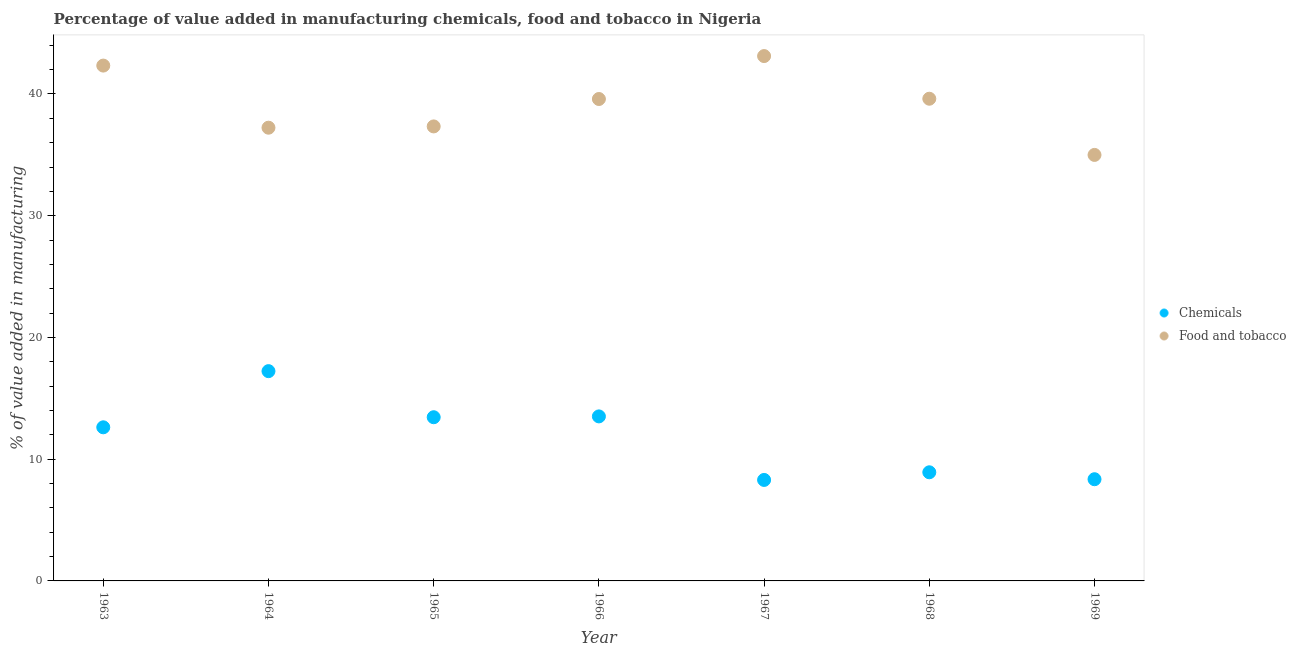What is the value added by  manufacturing chemicals in 1965?
Make the answer very short. 13.45. Across all years, what is the maximum value added by  manufacturing chemicals?
Offer a terse response. 17.23. Across all years, what is the minimum value added by manufacturing food and tobacco?
Offer a very short reply. 34.99. In which year was the value added by manufacturing food and tobacco maximum?
Give a very brief answer. 1967. In which year was the value added by manufacturing food and tobacco minimum?
Your answer should be compact. 1969. What is the total value added by manufacturing food and tobacco in the graph?
Provide a succinct answer. 274.21. What is the difference between the value added by manufacturing food and tobacco in 1966 and that in 1969?
Ensure brevity in your answer.  4.59. What is the difference between the value added by  manufacturing chemicals in 1963 and the value added by manufacturing food and tobacco in 1967?
Your response must be concise. -30.5. What is the average value added by  manufacturing chemicals per year?
Keep it short and to the point. 11.77. In the year 1965, what is the difference between the value added by manufacturing food and tobacco and value added by  manufacturing chemicals?
Your response must be concise. 23.89. What is the ratio of the value added by  manufacturing chemicals in 1963 to that in 1966?
Provide a short and direct response. 0.93. Is the value added by  manufacturing chemicals in 1963 less than that in 1966?
Make the answer very short. Yes. What is the difference between the highest and the second highest value added by manufacturing food and tobacco?
Ensure brevity in your answer.  0.78. What is the difference between the highest and the lowest value added by  manufacturing chemicals?
Give a very brief answer. 8.94. Is the sum of the value added by manufacturing food and tobacco in 1968 and 1969 greater than the maximum value added by  manufacturing chemicals across all years?
Provide a succinct answer. Yes. Does the value added by manufacturing food and tobacco monotonically increase over the years?
Give a very brief answer. No. Is the value added by  manufacturing chemicals strictly less than the value added by manufacturing food and tobacco over the years?
Offer a very short reply. Yes. Does the graph contain any zero values?
Your answer should be compact. No. Does the graph contain grids?
Your answer should be compact. No. Where does the legend appear in the graph?
Provide a short and direct response. Center right. How many legend labels are there?
Your answer should be very brief. 2. What is the title of the graph?
Offer a terse response. Percentage of value added in manufacturing chemicals, food and tobacco in Nigeria. Does "Lowest 20% of population" appear as one of the legend labels in the graph?
Offer a terse response. No. What is the label or title of the X-axis?
Keep it short and to the point. Year. What is the label or title of the Y-axis?
Your response must be concise. % of value added in manufacturing. What is the % of value added in manufacturing of Chemicals in 1963?
Offer a very short reply. 12.62. What is the % of value added in manufacturing in Food and tobacco in 1963?
Your answer should be compact. 42.33. What is the % of value added in manufacturing in Chemicals in 1964?
Keep it short and to the point. 17.23. What is the % of value added in manufacturing of Food and tobacco in 1964?
Provide a short and direct response. 37.23. What is the % of value added in manufacturing of Chemicals in 1965?
Make the answer very short. 13.45. What is the % of value added in manufacturing in Food and tobacco in 1965?
Offer a terse response. 37.34. What is the % of value added in manufacturing of Chemicals in 1966?
Provide a short and direct response. 13.52. What is the % of value added in manufacturing in Food and tobacco in 1966?
Your answer should be compact. 39.59. What is the % of value added in manufacturing of Chemicals in 1967?
Your answer should be compact. 8.3. What is the % of value added in manufacturing in Food and tobacco in 1967?
Offer a terse response. 43.12. What is the % of value added in manufacturing in Chemicals in 1968?
Your answer should be very brief. 8.92. What is the % of value added in manufacturing in Food and tobacco in 1968?
Provide a succinct answer. 39.61. What is the % of value added in manufacturing in Chemicals in 1969?
Offer a very short reply. 8.35. What is the % of value added in manufacturing in Food and tobacco in 1969?
Your answer should be very brief. 34.99. Across all years, what is the maximum % of value added in manufacturing of Chemicals?
Offer a terse response. 17.23. Across all years, what is the maximum % of value added in manufacturing in Food and tobacco?
Give a very brief answer. 43.12. Across all years, what is the minimum % of value added in manufacturing in Chemicals?
Keep it short and to the point. 8.3. Across all years, what is the minimum % of value added in manufacturing of Food and tobacco?
Provide a short and direct response. 34.99. What is the total % of value added in manufacturing in Chemicals in the graph?
Provide a short and direct response. 82.39. What is the total % of value added in manufacturing in Food and tobacco in the graph?
Provide a short and direct response. 274.21. What is the difference between the % of value added in manufacturing of Chemicals in 1963 and that in 1964?
Your response must be concise. -4.61. What is the difference between the % of value added in manufacturing in Food and tobacco in 1963 and that in 1964?
Your answer should be very brief. 5.1. What is the difference between the % of value added in manufacturing of Chemicals in 1963 and that in 1965?
Offer a very short reply. -0.83. What is the difference between the % of value added in manufacturing of Food and tobacco in 1963 and that in 1965?
Provide a succinct answer. 5. What is the difference between the % of value added in manufacturing in Chemicals in 1963 and that in 1966?
Ensure brevity in your answer.  -0.9. What is the difference between the % of value added in manufacturing of Food and tobacco in 1963 and that in 1966?
Your response must be concise. 2.75. What is the difference between the % of value added in manufacturing in Chemicals in 1963 and that in 1967?
Your answer should be compact. 4.32. What is the difference between the % of value added in manufacturing in Food and tobacco in 1963 and that in 1967?
Keep it short and to the point. -0.78. What is the difference between the % of value added in manufacturing in Chemicals in 1963 and that in 1968?
Your answer should be compact. 3.7. What is the difference between the % of value added in manufacturing of Food and tobacco in 1963 and that in 1968?
Your answer should be compact. 2.72. What is the difference between the % of value added in manufacturing in Chemicals in 1963 and that in 1969?
Your response must be concise. 4.26. What is the difference between the % of value added in manufacturing of Food and tobacco in 1963 and that in 1969?
Ensure brevity in your answer.  7.34. What is the difference between the % of value added in manufacturing of Chemicals in 1964 and that in 1965?
Your answer should be very brief. 3.79. What is the difference between the % of value added in manufacturing of Food and tobacco in 1964 and that in 1965?
Your answer should be very brief. -0.11. What is the difference between the % of value added in manufacturing of Chemicals in 1964 and that in 1966?
Provide a succinct answer. 3.72. What is the difference between the % of value added in manufacturing of Food and tobacco in 1964 and that in 1966?
Make the answer very short. -2.36. What is the difference between the % of value added in manufacturing of Chemicals in 1964 and that in 1967?
Ensure brevity in your answer.  8.94. What is the difference between the % of value added in manufacturing in Food and tobacco in 1964 and that in 1967?
Keep it short and to the point. -5.88. What is the difference between the % of value added in manufacturing in Chemicals in 1964 and that in 1968?
Keep it short and to the point. 8.31. What is the difference between the % of value added in manufacturing of Food and tobacco in 1964 and that in 1968?
Provide a succinct answer. -2.38. What is the difference between the % of value added in manufacturing of Chemicals in 1964 and that in 1969?
Keep it short and to the point. 8.88. What is the difference between the % of value added in manufacturing in Food and tobacco in 1964 and that in 1969?
Your answer should be very brief. 2.24. What is the difference between the % of value added in manufacturing of Chemicals in 1965 and that in 1966?
Your answer should be very brief. -0.07. What is the difference between the % of value added in manufacturing of Food and tobacco in 1965 and that in 1966?
Your answer should be very brief. -2.25. What is the difference between the % of value added in manufacturing of Chemicals in 1965 and that in 1967?
Make the answer very short. 5.15. What is the difference between the % of value added in manufacturing of Food and tobacco in 1965 and that in 1967?
Keep it short and to the point. -5.78. What is the difference between the % of value added in manufacturing of Chemicals in 1965 and that in 1968?
Your answer should be very brief. 4.52. What is the difference between the % of value added in manufacturing of Food and tobacco in 1965 and that in 1968?
Give a very brief answer. -2.27. What is the difference between the % of value added in manufacturing in Chemicals in 1965 and that in 1969?
Ensure brevity in your answer.  5.09. What is the difference between the % of value added in manufacturing of Food and tobacco in 1965 and that in 1969?
Your response must be concise. 2.34. What is the difference between the % of value added in manufacturing of Chemicals in 1966 and that in 1967?
Make the answer very short. 5.22. What is the difference between the % of value added in manufacturing in Food and tobacco in 1966 and that in 1967?
Make the answer very short. -3.53. What is the difference between the % of value added in manufacturing in Chemicals in 1966 and that in 1968?
Provide a short and direct response. 4.59. What is the difference between the % of value added in manufacturing of Food and tobacco in 1966 and that in 1968?
Make the answer very short. -0.02. What is the difference between the % of value added in manufacturing in Chemicals in 1966 and that in 1969?
Your answer should be very brief. 5.16. What is the difference between the % of value added in manufacturing of Food and tobacco in 1966 and that in 1969?
Your answer should be very brief. 4.59. What is the difference between the % of value added in manufacturing of Chemicals in 1967 and that in 1968?
Your answer should be compact. -0.63. What is the difference between the % of value added in manufacturing of Food and tobacco in 1967 and that in 1968?
Your answer should be very brief. 3.5. What is the difference between the % of value added in manufacturing of Chemicals in 1967 and that in 1969?
Provide a short and direct response. -0.06. What is the difference between the % of value added in manufacturing of Food and tobacco in 1967 and that in 1969?
Make the answer very short. 8.12. What is the difference between the % of value added in manufacturing in Chemicals in 1968 and that in 1969?
Make the answer very short. 0.57. What is the difference between the % of value added in manufacturing in Food and tobacco in 1968 and that in 1969?
Make the answer very short. 4.62. What is the difference between the % of value added in manufacturing of Chemicals in 1963 and the % of value added in manufacturing of Food and tobacco in 1964?
Make the answer very short. -24.61. What is the difference between the % of value added in manufacturing of Chemicals in 1963 and the % of value added in manufacturing of Food and tobacco in 1965?
Your response must be concise. -24.72. What is the difference between the % of value added in manufacturing in Chemicals in 1963 and the % of value added in manufacturing in Food and tobacco in 1966?
Provide a succinct answer. -26.97. What is the difference between the % of value added in manufacturing of Chemicals in 1963 and the % of value added in manufacturing of Food and tobacco in 1967?
Ensure brevity in your answer.  -30.5. What is the difference between the % of value added in manufacturing in Chemicals in 1963 and the % of value added in manufacturing in Food and tobacco in 1968?
Your response must be concise. -26.99. What is the difference between the % of value added in manufacturing in Chemicals in 1963 and the % of value added in manufacturing in Food and tobacco in 1969?
Your response must be concise. -22.38. What is the difference between the % of value added in manufacturing in Chemicals in 1964 and the % of value added in manufacturing in Food and tobacco in 1965?
Provide a short and direct response. -20.1. What is the difference between the % of value added in manufacturing of Chemicals in 1964 and the % of value added in manufacturing of Food and tobacco in 1966?
Give a very brief answer. -22.36. What is the difference between the % of value added in manufacturing of Chemicals in 1964 and the % of value added in manufacturing of Food and tobacco in 1967?
Keep it short and to the point. -25.88. What is the difference between the % of value added in manufacturing in Chemicals in 1964 and the % of value added in manufacturing in Food and tobacco in 1968?
Keep it short and to the point. -22.38. What is the difference between the % of value added in manufacturing in Chemicals in 1964 and the % of value added in manufacturing in Food and tobacco in 1969?
Offer a very short reply. -17.76. What is the difference between the % of value added in manufacturing in Chemicals in 1965 and the % of value added in manufacturing in Food and tobacco in 1966?
Offer a very short reply. -26.14. What is the difference between the % of value added in manufacturing in Chemicals in 1965 and the % of value added in manufacturing in Food and tobacco in 1967?
Keep it short and to the point. -29.67. What is the difference between the % of value added in manufacturing of Chemicals in 1965 and the % of value added in manufacturing of Food and tobacco in 1968?
Give a very brief answer. -26.16. What is the difference between the % of value added in manufacturing of Chemicals in 1965 and the % of value added in manufacturing of Food and tobacco in 1969?
Ensure brevity in your answer.  -21.55. What is the difference between the % of value added in manufacturing in Chemicals in 1966 and the % of value added in manufacturing in Food and tobacco in 1967?
Provide a short and direct response. -29.6. What is the difference between the % of value added in manufacturing of Chemicals in 1966 and the % of value added in manufacturing of Food and tobacco in 1968?
Give a very brief answer. -26.1. What is the difference between the % of value added in manufacturing of Chemicals in 1966 and the % of value added in manufacturing of Food and tobacco in 1969?
Your answer should be very brief. -21.48. What is the difference between the % of value added in manufacturing in Chemicals in 1967 and the % of value added in manufacturing in Food and tobacco in 1968?
Offer a very short reply. -31.32. What is the difference between the % of value added in manufacturing of Chemicals in 1967 and the % of value added in manufacturing of Food and tobacco in 1969?
Provide a succinct answer. -26.7. What is the difference between the % of value added in manufacturing in Chemicals in 1968 and the % of value added in manufacturing in Food and tobacco in 1969?
Your response must be concise. -26.07. What is the average % of value added in manufacturing of Chemicals per year?
Offer a very short reply. 11.77. What is the average % of value added in manufacturing in Food and tobacco per year?
Make the answer very short. 39.17. In the year 1963, what is the difference between the % of value added in manufacturing in Chemicals and % of value added in manufacturing in Food and tobacco?
Your response must be concise. -29.71. In the year 1964, what is the difference between the % of value added in manufacturing in Chemicals and % of value added in manufacturing in Food and tobacco?
Your answer should be very brief. -20. In the year 1965, what is the difference between the % of value added in manufacturing in Chemicals and % of value added in manufacturing in Food and tobacco?
Offer a terse response. -23.89. In the year 1966, what is the difference between the % of value added in manufacturing in Chemicals and % of value added in manufacturing in Food and tobacco?
Your answer should be very brief. -26.07. In the year 1967, what is the difference between the % of value added in manufacturing in Chemicals and % of value added in manufacturing in Food and tobacco?
Make the answer very short. -34.82. In the year 1968, what is the difference between the % of value added in manufacturing of Chemicals and % of value added in manufacturing of Food and tobacco?
Provide a short and direct response. -30.69. In the year 1969, what is the difference between the % of value added in manufacturing of Chemicals and % of value added in manufacturing of Food and tobacco?
Provide a short and direct response. -26.64. What is the ratio of the % of value added in manufacturing of Chemicals in 1963 to that in 1964?
Offer a terse response. 0.73. What is the ratio of the % of value added in manufacturing of Food and tobacco in 1963 to that in 1964?
Offer a terse response. 1.14. What is the ratio of the % of value added in manufacturing of Chemicals in 1963 to that in 1965?
Make the answer very short. 0.94. What is the ratio of the % of value added in manufacturing in Food and tobacco in 1963 to that in 1965?
Provide a succinct answer. 1.13. What is the ratio of the % of value added in manufacturing of Chemicals in 1963 to that in 1966?
Provide a succinct answer. 0.93. What is the ratio of the % of value added in manufacturing in Food and tobacco in 1963 to that in 1966?
Keep it short and to the point. 1.07. What is the ratio of the % of value added in manufacturing in Chemicals in 1963 to that in 1967?
Keep it short and to the point. 1.52. What is the ratio of the % of value added in manufacturing of Food and tobacco in 1963 to that in 1967?
Your answer should be very brief. 0.98. What is the ratio of the % of value added in manufacturing in Chemicals in 1963 to that in 1968?
Give a very brief answer. 1.41. What is the ratio of the % of value added in manufacturing of Food and tobacco in 1963 to that in 1968?
Make the answer very short. 1.07. What is the ratio of the % of value added in manufacturing in Chemicals in 1963 to that in 1969?
Give a very brief answer. 1.51. What is the ratio of the % of value added in manufacturing of Food and tobacco in 1963 to that in 1969?
Provide a succinct answer. 1.21. What is the ratio of the % of value added in manufacturing of Chemicals in 1964 to that in 1965?
Your answer should be very brief. 1.28. What is the ratio of the % of value added in manufacturing of Chemicals in 1964 to that in 1966?
Keep it short and to the point. 1.28. What is the ratio of the % of value added in manufacturing in Food and tobacco in 1964 to that in 1966?
Ensure brevity in your answer.  0.94. What is the ratio of the % of value added in manufacturing of Chemicals in 1964 to that in 1967?
Ensure brevity in your answer.  2.08. What is the ratio of the % of value added in manufacturing of Food and tobacco in 1964 to that in 1967?
Provide a short and direct response. 0.86. What is the ratio of the % of value added in manufacturing in Chemicals in 1964 to that in 1968?
Ensure brevity in your answer.  1.93. What is the ratio of the % of value added in manufacturing of Food and tobacco in 1964 to that in 1968?
Offer a very short reply. 0.94. What is the ratio of the % of value added in manufacturing in Chemicals in 1964 to that in 1969?
Provide a short and direct response. 2.06. What is the ratio of the % of value added in manufacturing in Food and tobacco in 1964 to that in 1969?
Your answer should be very brief. 1.06. What is the ratio of the % of value added in manufacturing of Chemicals in 1965 to that in 1966?
Keep it short and to the point. 0.99. What is the ratio of the % of value added in manufacturing of Food and tobacco in 1965 to that in 1966?
Your response must be concise. 0.94. What is the ratio of the % of value added in manufacturing in Chemicals in 1965 to that in 1967?
Your answer should be very brief. 1.62. What is the ratio of the % of value added in manufacturing in Food and tobacco in 1965 to that in 1967?
Provide a short and direct response. 0.87. What is the ratio of the % of value added in manufacturing of Chemicals in 1965 to that in 1968?
Provide a short and direct response. 1.51. What is the ratio of the % of value added in manufacturing in Food and tobacco in 1965 to that in 1968?
Give a very brief answer. 0.94. What is the ratio of the % of value added in manufacturing of Chemicals in 1965 to that in 1969?
Offer a very short reply. 1.61. What is the ratio of the % of value added in manufacturing in Food and tobacco in 1965 to that in 1969?
Offer a terse response. 1.07. What is the ratio of the % of value added in manufacturing of Chemicals in 1966 to that in 1967?
Give a very brief answer. 1.63. What is the ratio of the % of value added in manufacturing in Food and tobacco in 1966 to that in 1967?
Provide a short and direct response. 0.92. What is the ratio of the % of value added in manufacturing in Chemicals in 1966 to that in 1968?
Provide a short and direct response. 1.51. What is the ratio of the % of value added in manufacturing in Food and tobacco in 1966 to that in 1968?
Your answer should be compact. 1. What is the ratio of the % of value added in manufacturing of Chemicals in 1966 to that in 1969?
Give a very brief answer. 1.62. What is the ratio of the % of value added in manufacturing in Food and tobacco in 1966 to that in 1969?
Give a very brief answer. 1.13. What is the ratio of the % of value added in manufacturing in Chemicals in 1967 to that in 1968?
Provide a succinct answer. 0.93. What is the ratio of the % of value added in manufacturing in Food and tobacco in 1967 to that in 1968?
Provide a succinct answer. 1.09. What is the ratio of the % of value added in manufacturing of Chemicals in 1967 to that in 1969?
Ensure brevity in your answer.  0.99. What is the ratio of the % of value added in manufacturing of Food and tobacco in 1967 to that in 1969?
Offer a terse response. 1.23. What is the ratio of the % of value added in manufacturing in Chemicals in 1968 to that in 1969?
Ensure brevity in your answer.  1.07. What is the ratio of the % of value added in manufacturing in Food and tobacco in 1968 to that in 1969?
Your answer should be compact. 1.13. What is the difference between the highest and the second highest % of value added in manufacturing in Chemicals?
Your response must be concise. 3.72. What is the difference between the highest and the second highest % of value added in manufacturing in Food and tobacco?
Keep it short and to the point. 0.78. What is the difference between the highest and the lowest % of value added in manufacturing of Chemicals?
Offer a terse response. 8.94. What is the difference between the highest and the lowest % of value added in manufacturing in Food and tobacco?
Provide a short and direct response. 8.12. 